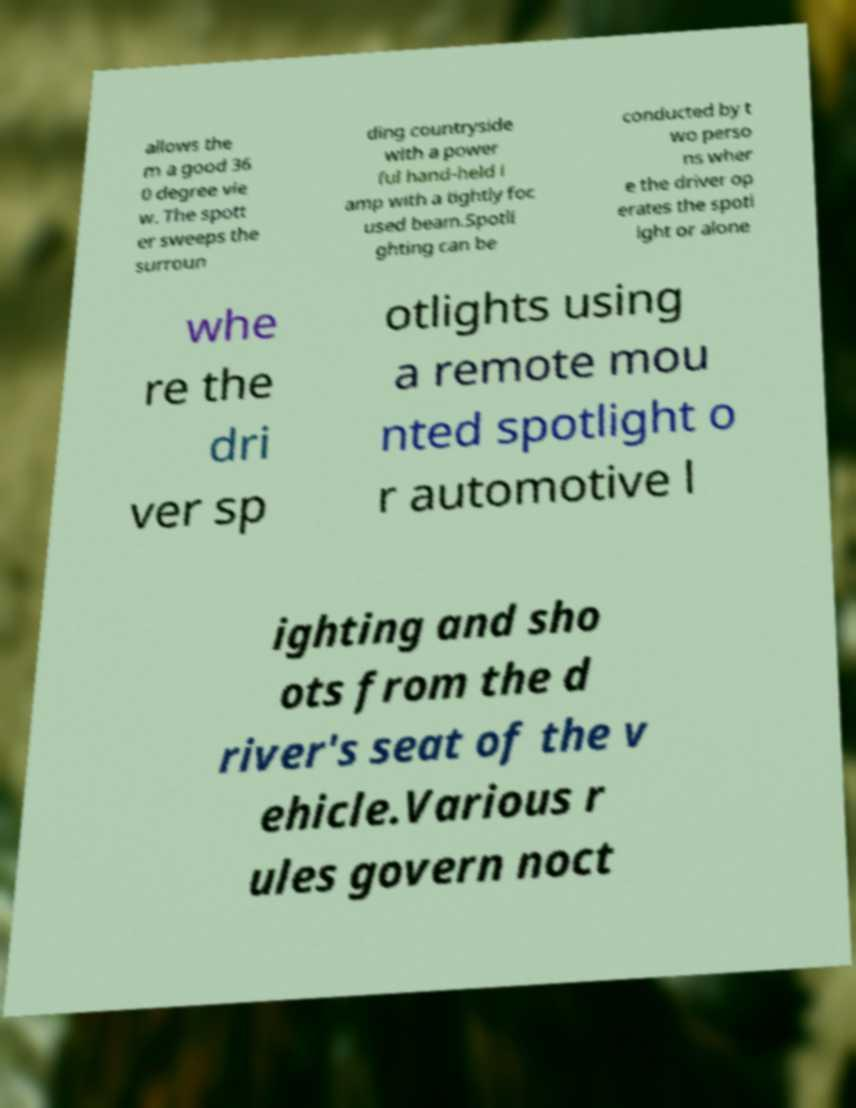I need the written content from this picture converted into text. Can you do that? allows the m a good 36 0 degree vie w. The spott er sweeps the surroun ding countryside with a power ful hand-held l amp with a tightly foc used beam.Spotli ghting can be conducted by t wo perso ns wher e the driver op erates the spotl ight or alone whe re the dri ver sp otlights using a remote mou nted spotlight o r automotive l ighting and sho ots from the d river's seat of the v ehicle.Various r ules govern noct 